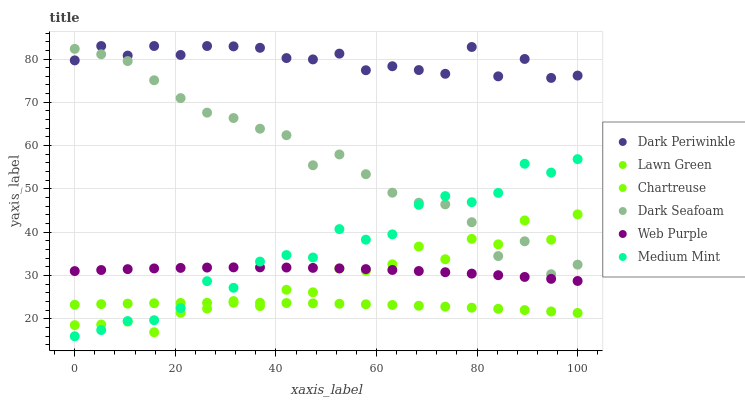Does Lawn Green have the minimum area under the curve?
Answer yes or no. Yes. Does Dark Periwinkle have the maximum area under the curve?
Answer yes or no. Yes. Does Web Purple have the minimum area under the curve?
Answer yes or no. No. Does Web Purple have the maximum area under the curve?
Answer yes or no. No. Is Lawn Green the smoothest?
Answer yes or no. Yes. Is Chartreuse the roughest?
Answer yes or no. Yes. Is Web Purple the smoothest?
Answer yes or no. No. Is Web Purple the roughest?
Answer yes or no. No. Does Medium Mint have the lowest value?
Answer yes or no. Yes. Does Lawn Green have the lowest value?
Answer yes or no. No. Does Dark Periwinkle have the highest value?
Answer yes or no. Yes. Does Web Purple have the highest value?
Answer yes or no. No. Is Chartreuse less than Dark Periwinkle?
Answer yes or no. Yes. Is Dark Seafoam greater than Web Purple?
Answer yes or no. Yes. Does Chartreuse intersect Dark Seafoam?
Answer yes or no. Yes. Is Chartreuse less than Dark Seafoam?
Answer yes or no. No. Is Chartreuse greater than Dark Seafoam?
Answer yes or no. No. Does Chartreuse intersect Dark Periwinkle?
Answer yes or no. No. 